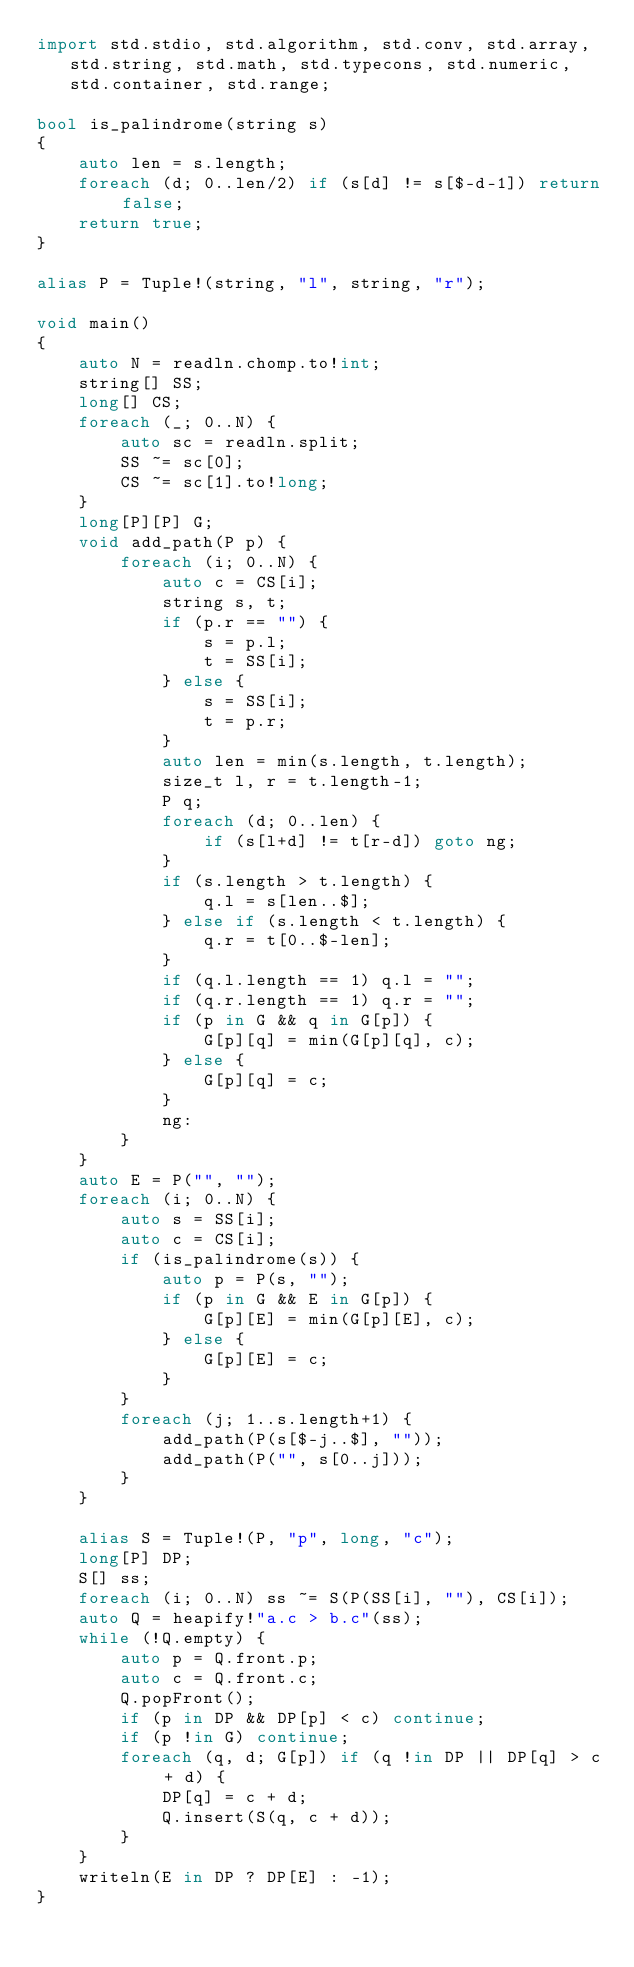Convert code to text. <code><loc_0><loc_0><loc_500><loc_500><_D_>import std.stdio, std.algorithm, std.conv, std.array, std.string, std.math, std.typecons, std.numeric, std.container, std.range;

bool is_palindrome(string s)
{
    auto len = s.length;
    foreach (d; 0..len/2) if (s[d] != s[$-d-1]) return false;
    return true;
}

alias P = Tuple!(string, "l", string, "r");

void main()
{
    auto N = readln.chomp.to!int;
    string[] SS;
    long[] CS;
    foreach (_; 0..N) {
        auto sc = readln.split;
        SS ~= sc[0];
        CS ~= sc[1].to!long;
    }
    long[P][P] G;
    void add_path(P p) {
        foreach (i; 0..N) {
            auto c = CS[i];
            string s, t;
            if (p.r == "") {
                s = p.l;
                t = SS[i];
            } else {
                s = SS[i];
                t = p.r;
            }
            auto len = min(s.length, t.length);
            size_t l, r = t.length-1;
            P q;
            foreach (d; 0..len) {
                if (s[l+d] != t[r-d]) goto ng;
            }
            if (s.length > t.length) {
                q.l = s[len..$];
            } else if (s.length < t.length) {
                q.r = t[0..$-len];
            }
            if (q.l.length == 1) q.l = "";
            if (q.r.length == 1) q.r = "";
            if (p in G && q in G[p]) {
                G[p][q] = min(G[p][q], c);
            } else {
                G[p][q] = c;
            }
            ng:
        }
    }
    auto E = P("", "");
    foreach (i; 0..N) {
        auto s = SS[i];
        auto c = CS[i];
        if (is_palindrome(s)) {
            auto p = P(s, "");
            if (p in G && E in G[p]) {
                G[p][E] = min(G[p][E], c);
            } else {
                G[p][E] = c;
            }
        }
        foreach (j; 1..s.length+1) {
            add_path(P(s[$-j..$], ""));
            add_path(P("", s[0..j]));
        }
    }

    alias S = Tuple!(P, "p", long, "c");
    long[P] DP;
    S[] ss;
    foreach (i; 0..N) ss ~= S(P(SS[i], ""), CS[i]);
    auto Q = heapify!"a.c > b.c"(ss);
    while (!Q.empty) {
        auto p = Q.front.p;
        auto c = Q.front.c;
        Q.popFront();
        if (p in DP && DP[p] < c) continue;
        if (p !in G) continue;
        foreach (q, d; G[p]) if (q !in DP || DP[q] > c + d) {
            DP[q] = c + d;
            Q.insert(S(q, c + d));
        }
    }
    writeln(E in DP ? DP[E] : -1);
}</code> 